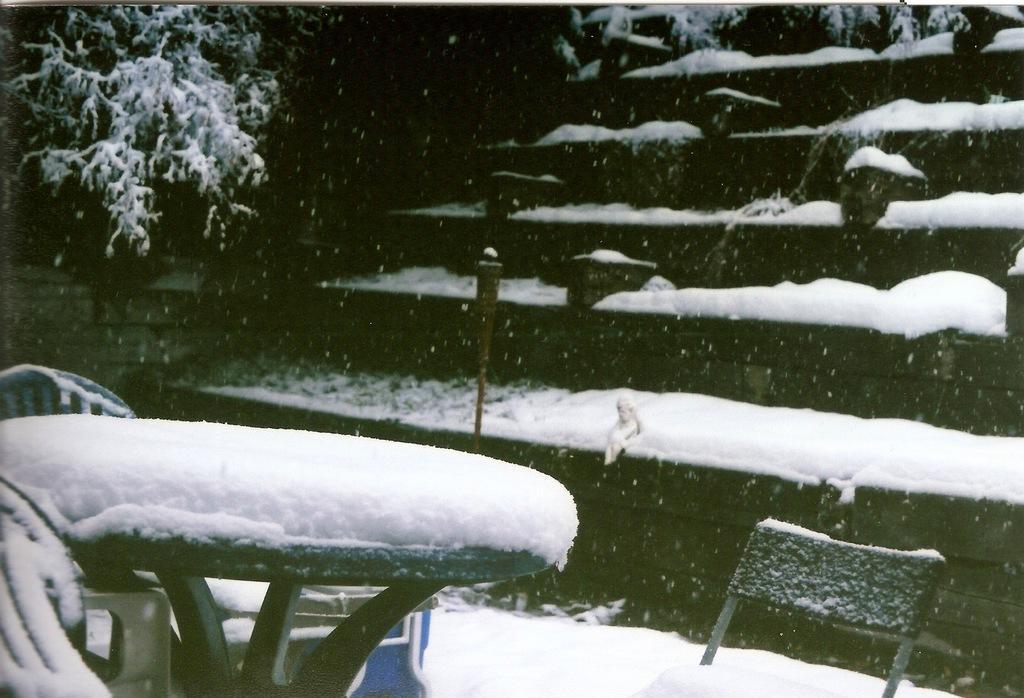Please provide a concise description of this image. It is the black and white image in which there is snow on the steps. In the middle there is a table around which there are chairs. Both the table and the chairs are covered with the snow. On the left side top there is a tree which is covered with the snow. 